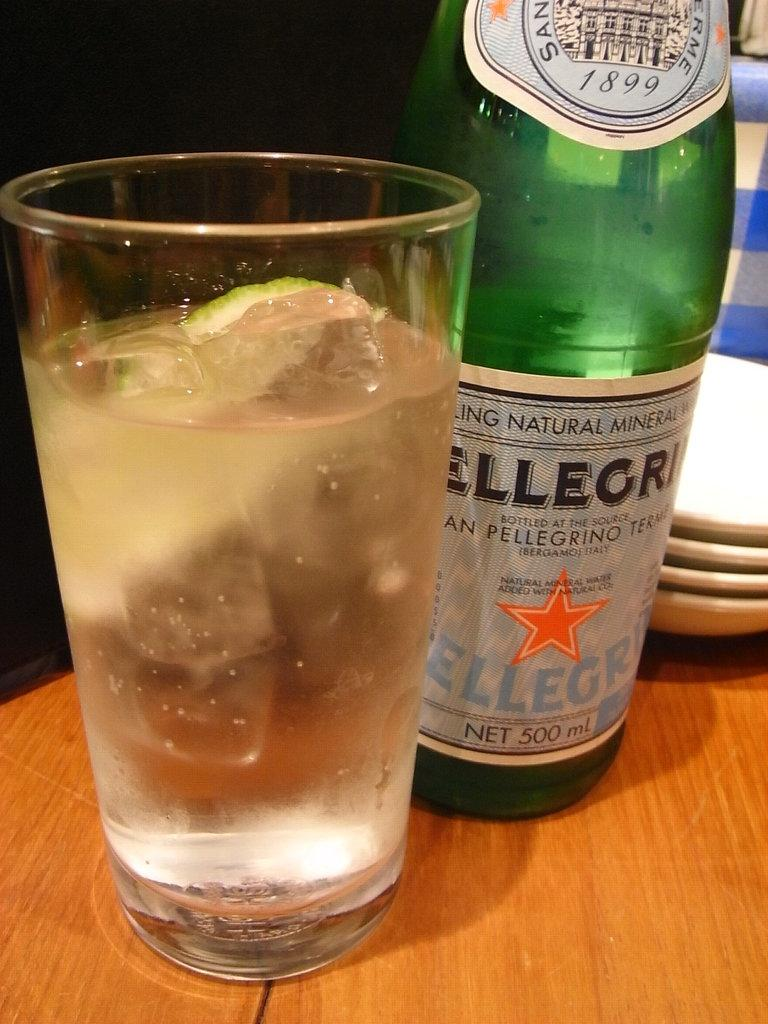<image>
Provide a brief description of the given image. A green bottle is labeled with the year 1899. 